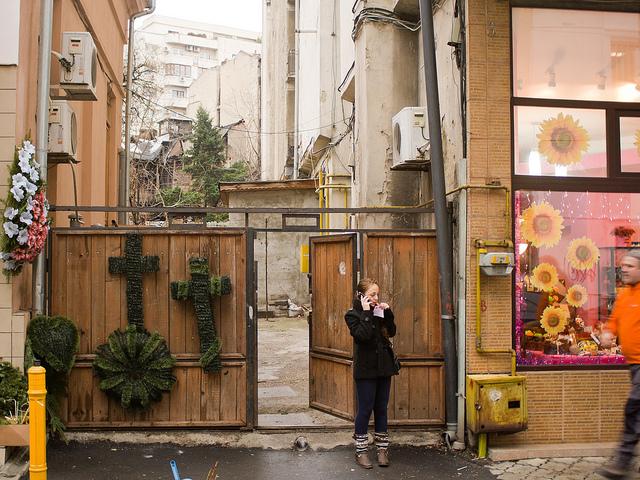What kind of flower is in the window?
Short answer required. Sunflower. What is this lady holding in her right hand?
Give a very brief answer. Phone. What color is the pole seen?
Be succinct. Black. What color are the flowers?
Give a very brief answer. Yellow. Is the lady sitting or standing?
Short answer required. Standing. What kind of building is she standing in front of?
Concise answer only. Church. How many people are there?
Write a very short answer. 1. 